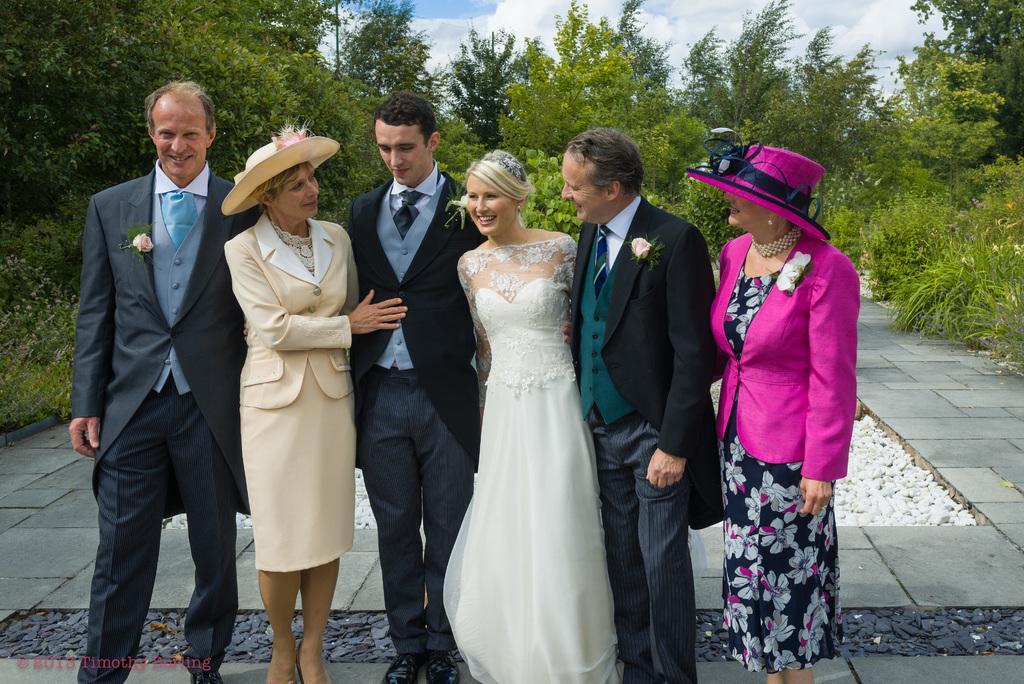In one or two sentences, can you explain what this image depicts? In the image we can see there are three men and three women standing, they are wearing clothes. This is a hat, a flower, earrings and a neck chain. This is a footpath, stones, watermark, trees and a cloudy sky. 